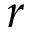<formula> <loc_0><loc_0><loc_500><loc_500>r</formula> 